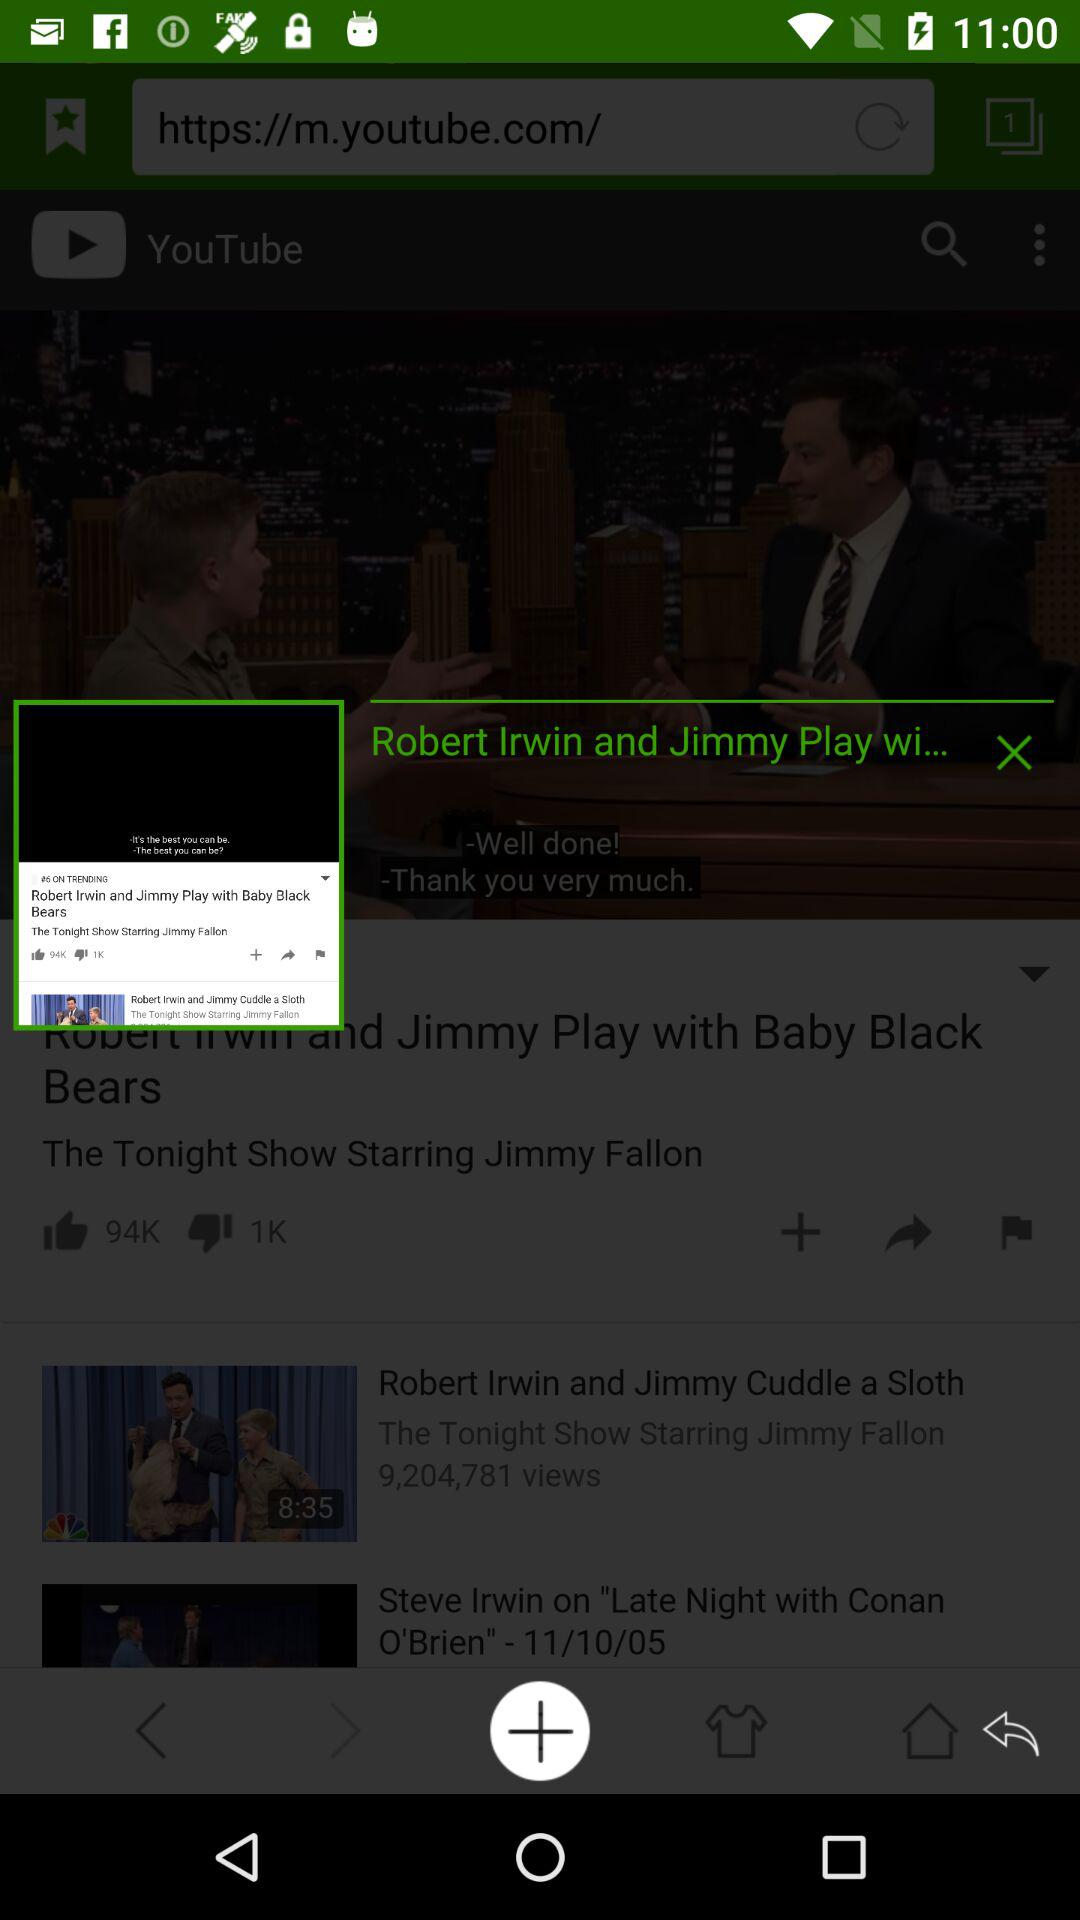What is the title of the video? The titles of the videos are "Robert Irwin and Jimmy Play wi...", "Robert Irwin and Jimmy Cuddle a Sloth" and "Steve Irwin on "Late Night with Conan O'Brien" - 11/10/05". 